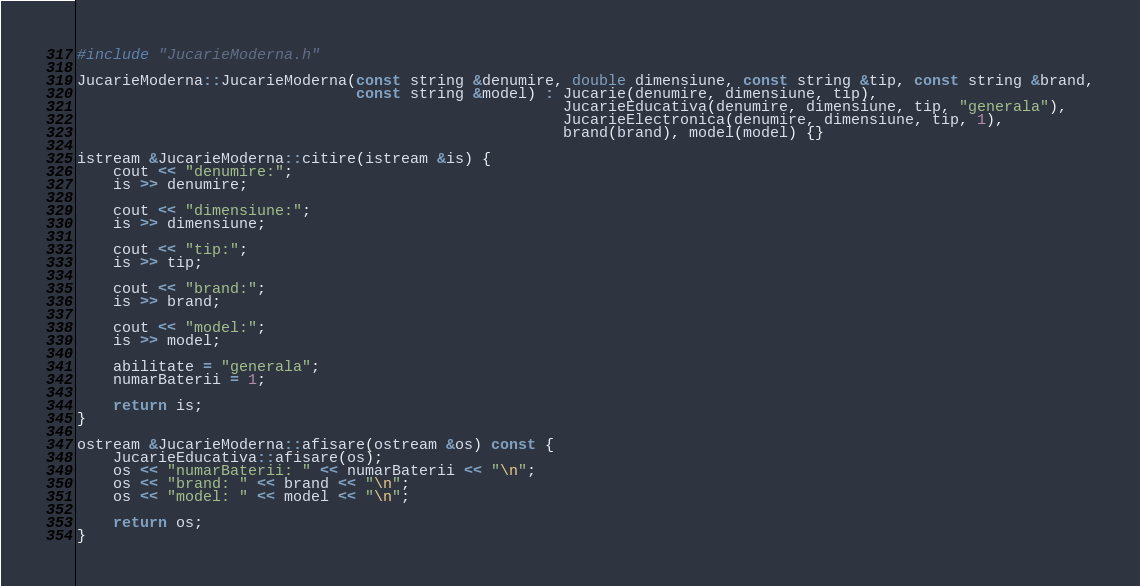Convert code to text. <code><loc_0><loc_0><loc_500><loc_500><_C++_>#include "JucarieModerna.h"

JucarieModerna::JucarieModerna(const string &denumire, double dimensiune, const string &tip, const string &brand,
                               const string &model) : Jucarie(denumire, dimensiune, tip),
                                                      JucarieEducativa(denumire, dimensiune, tip, "generala"),
                                                      JucarieElectronica(denumire, dimensiune, tip, 1),
                                                      brand(brand), model(model) {}

istream &JucarieModerna::citire(istream &is) {
    cout << "denumire:";
    is >> denumire;

    cout << "dimensiune:";
    is >> dimensiune;

    cout << "tip:";
    is >> tip;

    cout << "brand:";
    is >> brand;

    cout << "model:";
    is >> model;

    abilitate = "generala";
    numarBaterii = 1;

    return is;
}

ostream &JucarieModerna::afisare(ostream &os) const {
    JucarieEducativa::afisare(os);
    os << "numarBaterii: " << numarBaterii << "\n";
    os << "brand: " << brand << "\n";
    os << "model: " << model << "\n";

    return os;
}
</code> 